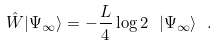<formula> <loc_0><loc_0><loc_500><loc_500>\hat { W } | \Psi _ { \infty } \rangle = - \frac { L } { 4 } \log 2 \ | \Psi _ { \infty } \rangle \ .</formula> 